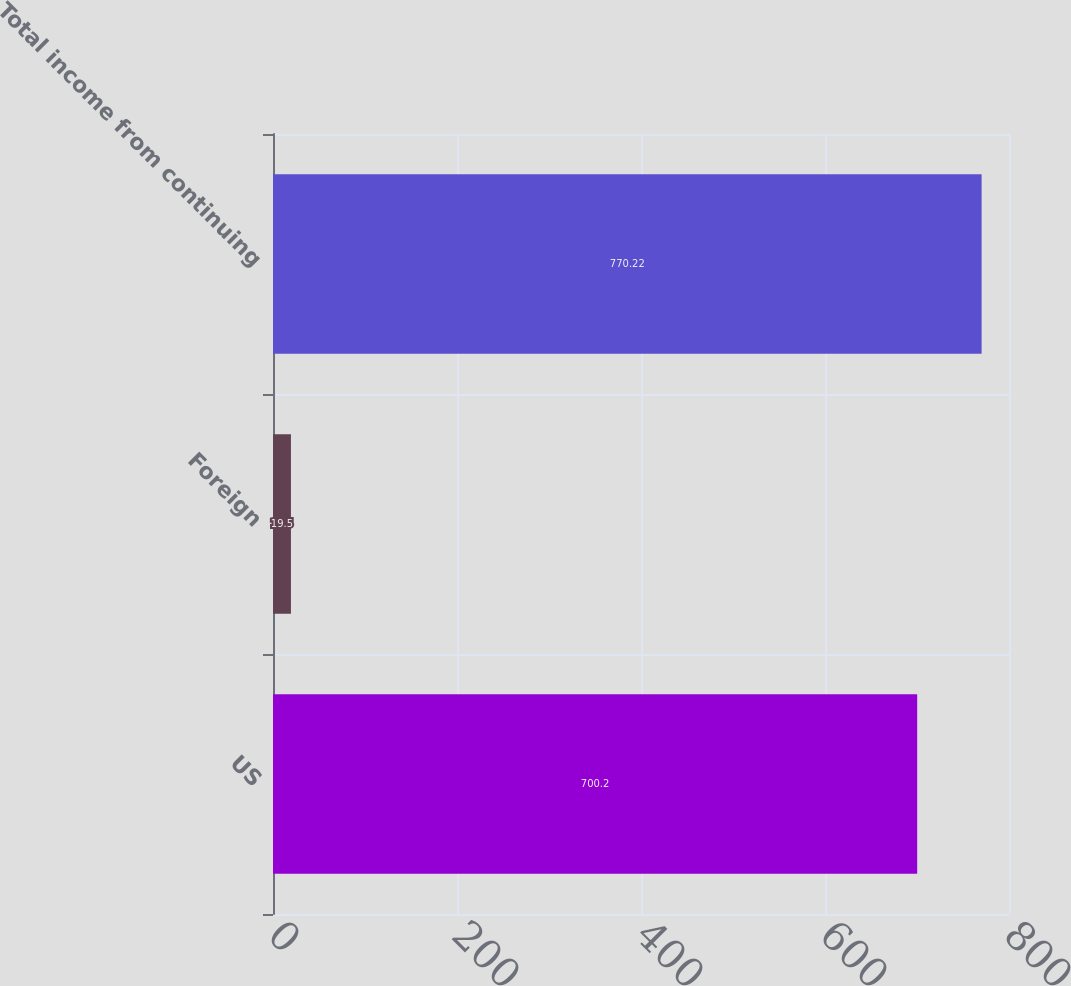Convert chart. <chart><loc_0><loc_0><loc_500><loc_500><bar_chart><fcel>US<fcel>Foreign<fcel>Total income from continuing<nl><fcel>700.2<fcel>19.5<fcel>770.22<nl></chart> 